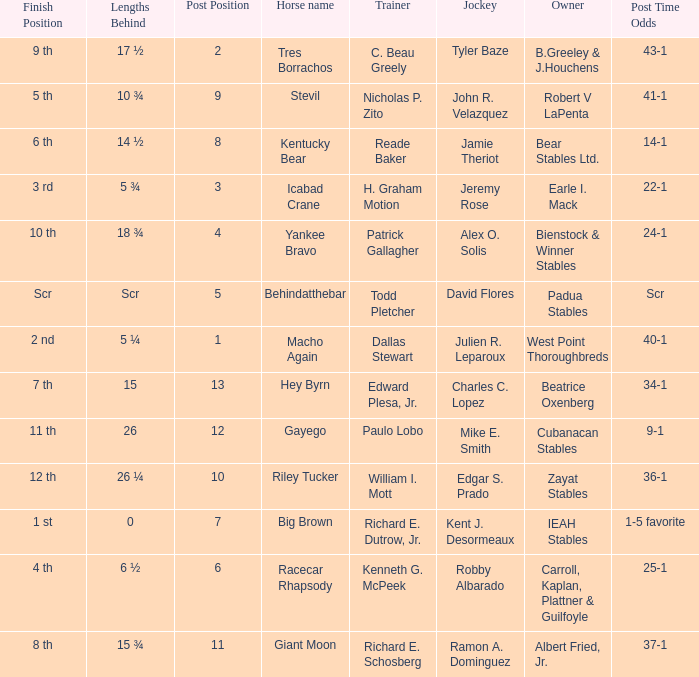Who is the owner of Icabad Crane? Earle I. Mack. 